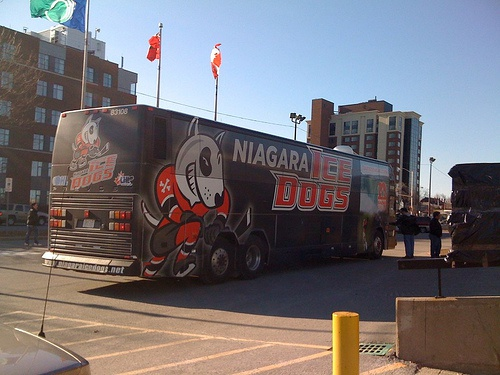Describe the objects in this image and their specific colors. I can see bus in lightblue, black, gray, and maroon tones, car in lightblue and gray tones, car in lightblue, black, and gray tones, people in lightblue, black, gray, and maroon tones, and people in lightblue, black, gray, and maroon tones in this image. 